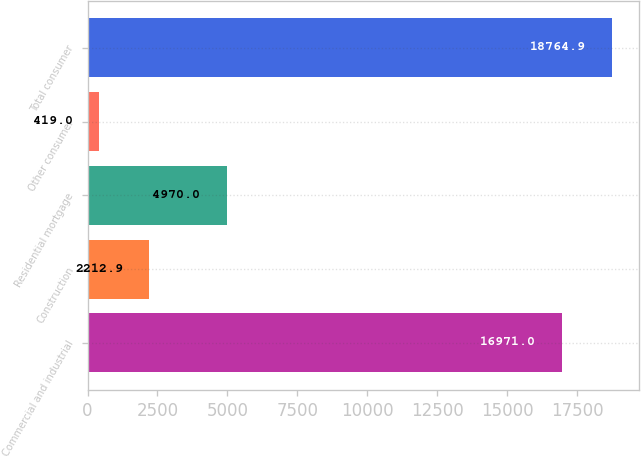Convert chart to OTSL. <chart><loc_0><loc_0><loc_500><loc_500><bar_chart><fcel>Commercial and industrial<fcel>Construction<fcel>Residential mortgage<fcel>Other consumer<fcel>Total consumer<nl><fcel>16971<fcel>2212.9<fcel>4970<fcel>419<fcel>18764.9<nl></chart> 